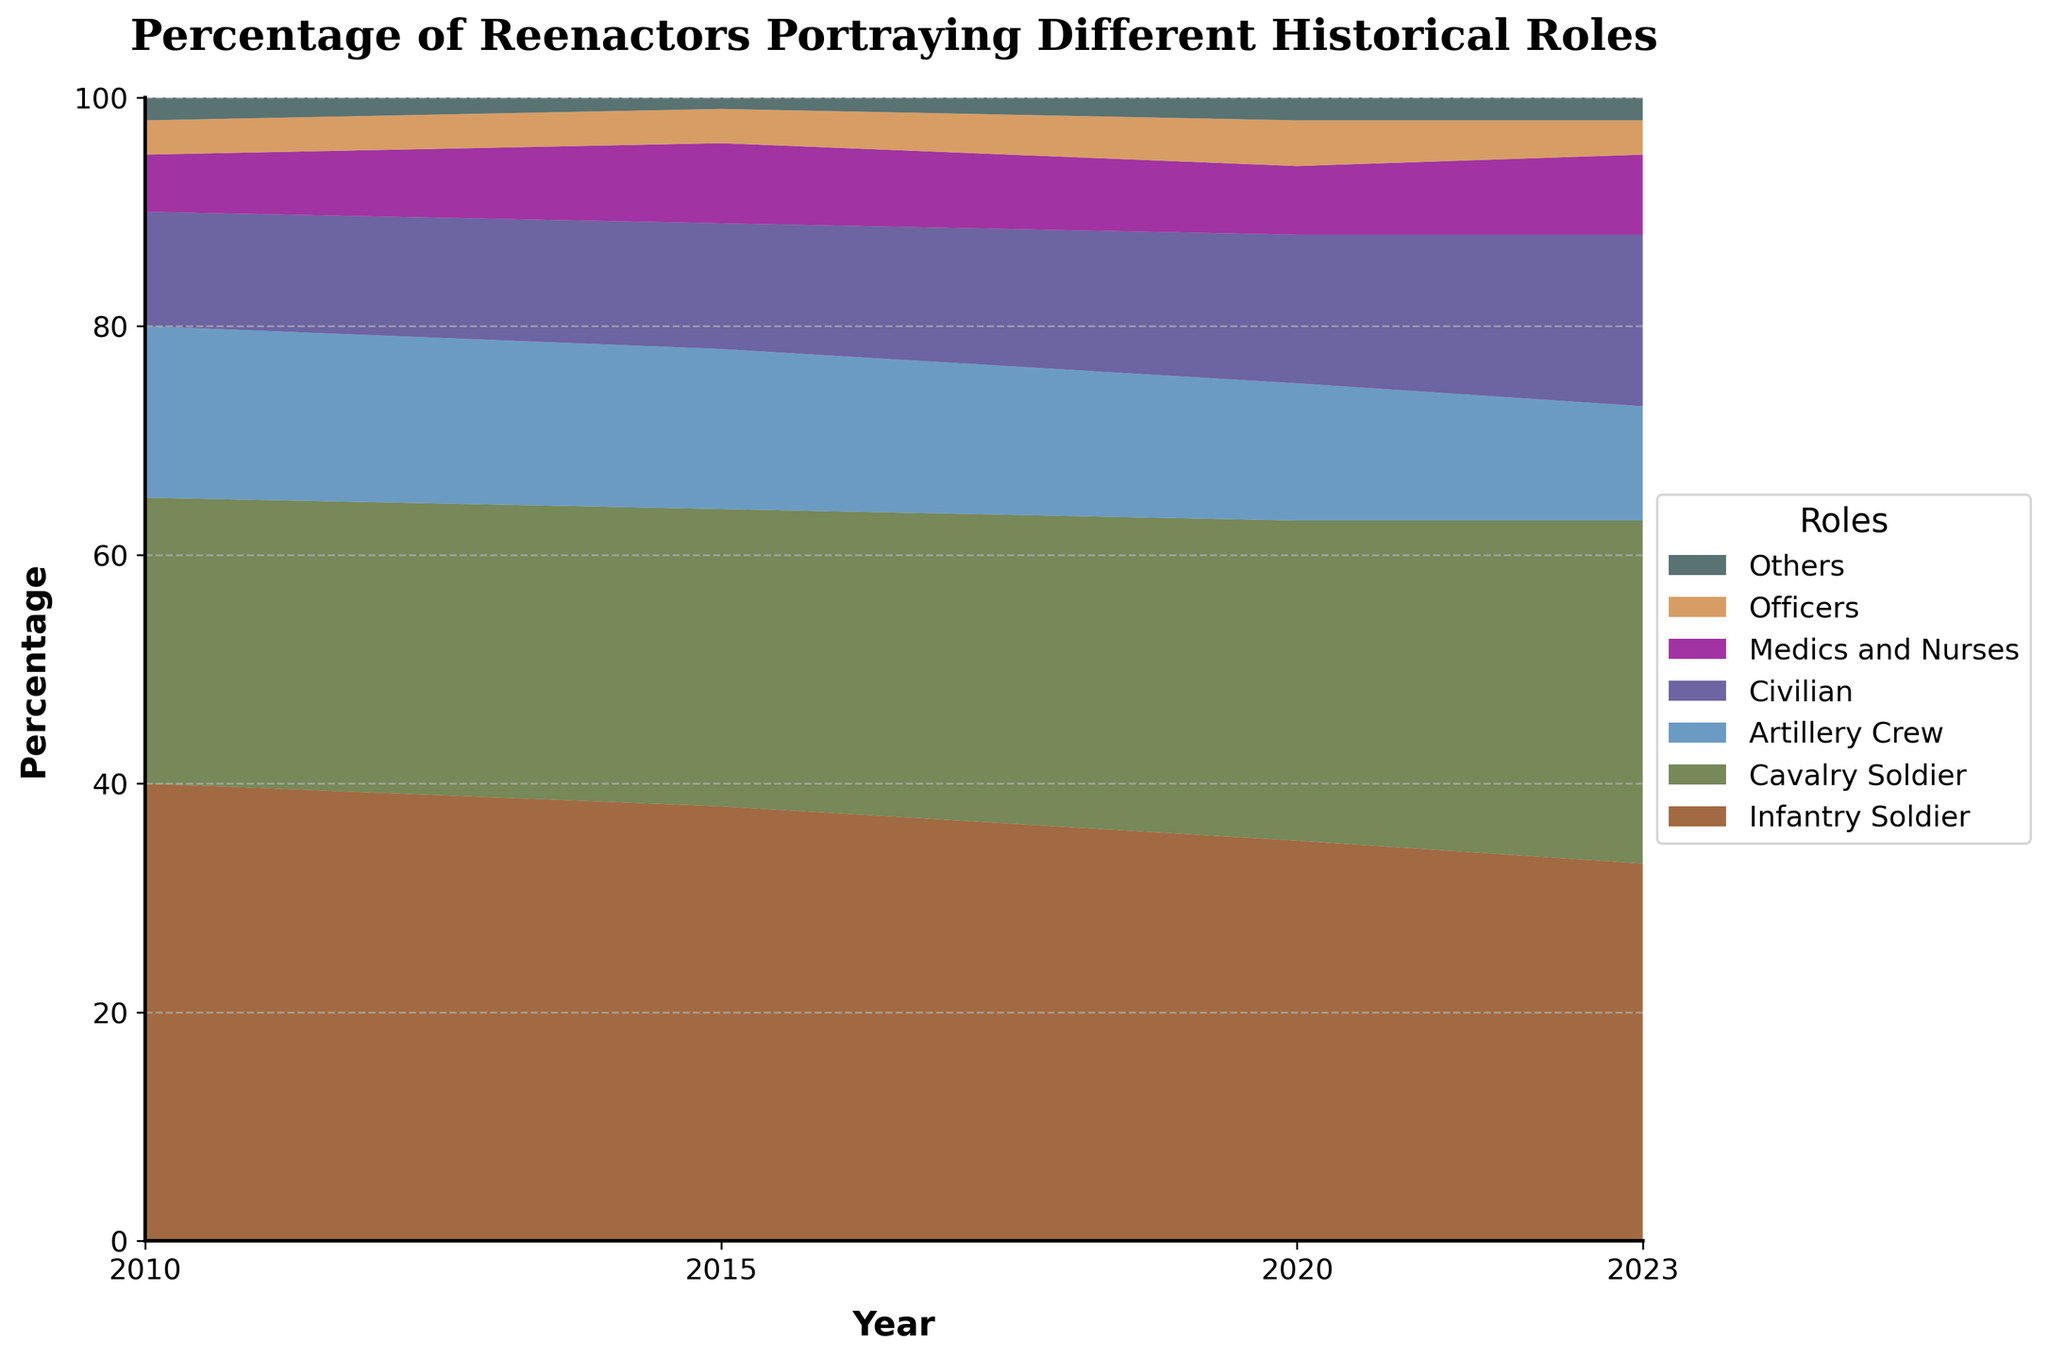What does the title of the chart say? The title of the chart gives an overview of what the chart represents. By looking at the top of the chart, the title is "Percentage of Reenactors Portraying Different Historical Roles".
Answer: Percentage of Reenactors Portraying Different Historical Roles Which role had the highest percentage of reenactors in 2010? By observing the chart at the year mark 2010, the area occupied by the "Infantry Soldier" role is the largest. Hence, "Infantry Soldier" had the highest percentage.
Answer: Infantry Soldier How did the percentage of Infantry Soldiers change from 2010 to 2023? From the chart, trace the "Infantry Soldier" area across the years. It starts at 40% in 2010 and decreases to 33% in 2023, indicating a decline.
Answer: Decrease In which year did the percentage of Civilian reenactors peak? Refer to the chart's "Civilian" segment across different years. The highest area for this role is seen in 2023 at 15%.
Answer: 2023 What is the total percentage of reenactors portraying Medics and Nurses, and Officers in 2015? From the 2015 mark, identify the percentage for Medics and Nurses (7%) and Officers (3%). Add them together.
Answer: 7% + 3% = 10% Compare the percentages of Cavalry Soldiers and Artillery Crew in 2020. Which role had a higher percentage and by how much? At the 2020 mark, the percentage for Cavalry Soldiers is 28%, and for Artillery Crew, it is 12%. Subtract the two to get the difference.
Answer: Cavalry Soldiers, by 16% What trend is noticeable in the percentage of Artillery Crew reenactors from 2010 to 2023? Observe the "Artillery Crew" area across the years. It progressively decreases from 15% in 2010 to 10% in 2023.
Answer: Decreasing trend How many roles are portrayed by reenactors in the chart? Count the different colored segments in the chart. There are seven distinct roles.
Answer: 7 Which role consistently has the smallest percentage of reenactors throughout the years? By comparing the base-most (smallest) segments for each year, "Others" consistently has the smallest area across all years.
Answer: Others 